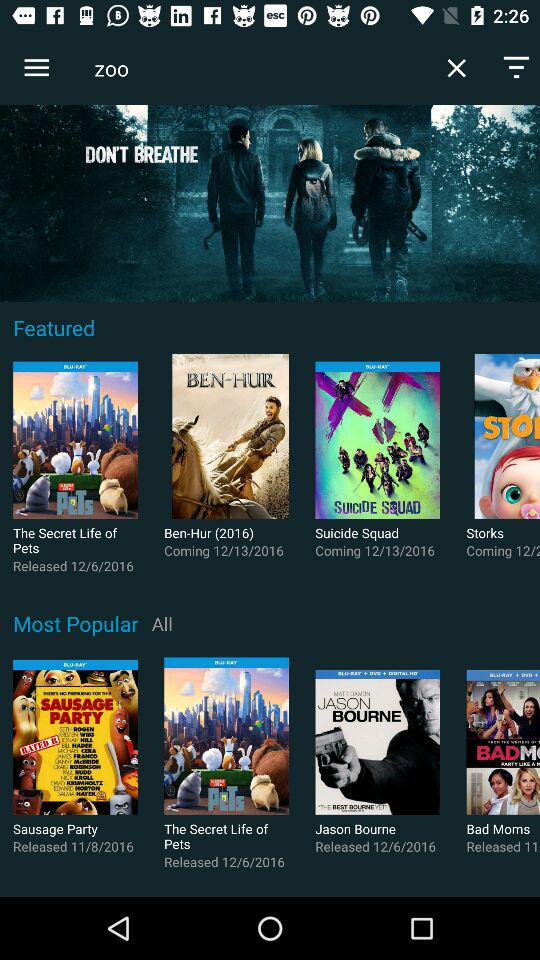What are the popular movies? The popular movies are "Sausage Party", "The Secret Life of Pets", "Jason Bourne" and "Bad Moms". 